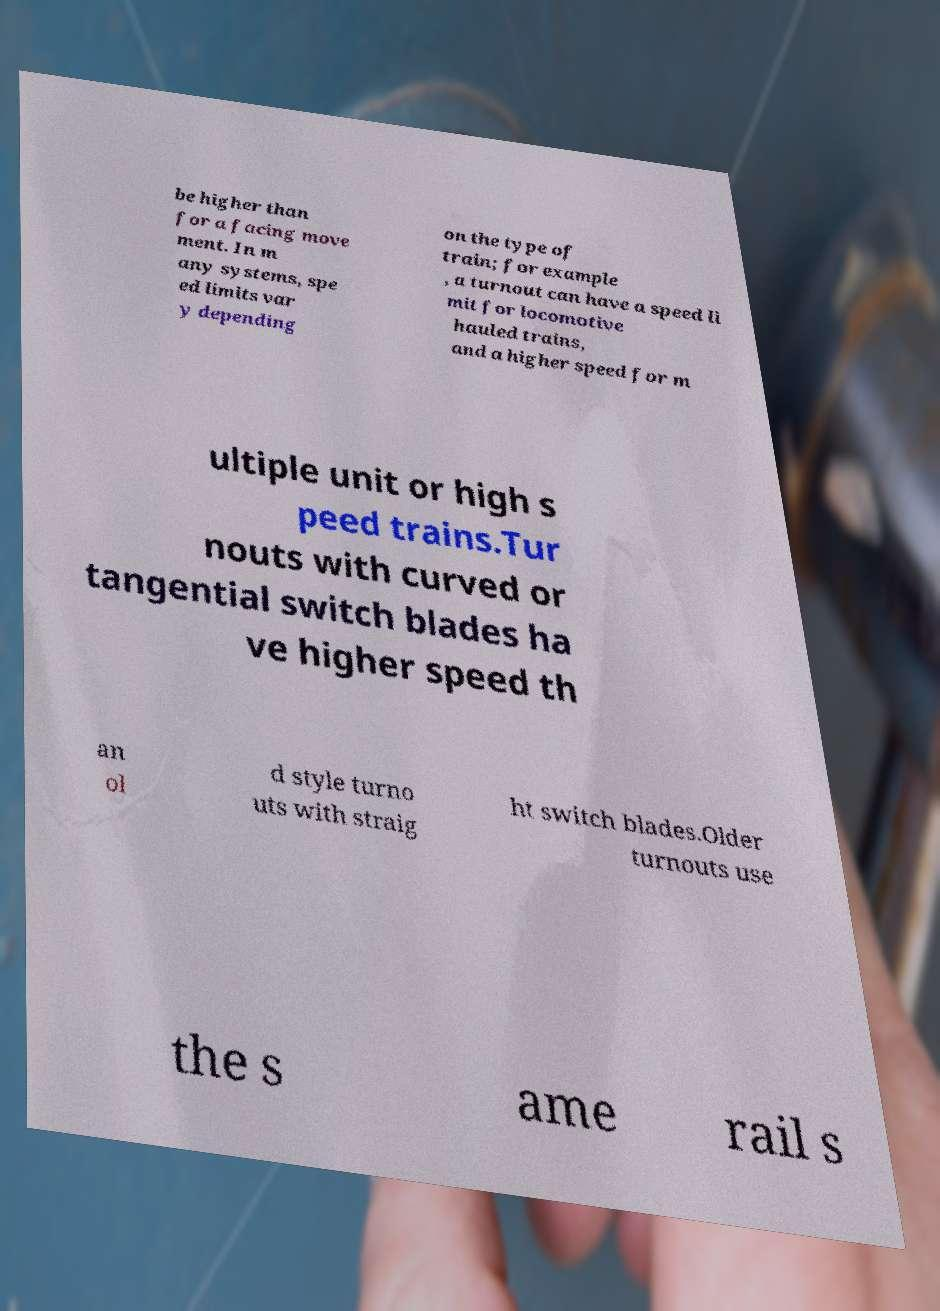What messages or text are displayed in this image? I need them in a readable, typed format. be higher than for a facing move ment. In m any systems, spe ed limits var y depending on the type of train; for example , a turnout can have a speed li mit for locomotive hauled trains, and a higher speed for m ultiple unit or high s peed trains.Tur nouts with curved or tangential switch blades ha ve higher speed th an ol d style turno uts with straig ht switch blades.Older turnouts use the s ame rail s 